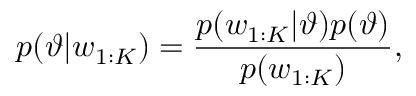<formula> <loc_0><loc_0><loc_500><loc_500>p ( \vartheta | w _ { 1 \colon K } ) = \frac { p ( w _ { 1 \colon K } | \vartheta ) p ( \vartheta ) } { p ( w _ { 1 \colon K } ) } ,</formula> 